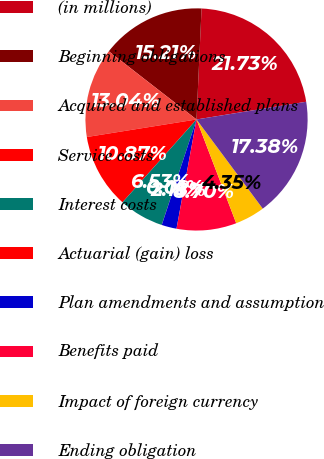Convert chart to OTSL. <chart><loc_0><loc_0><loc_500><loc_500><pie_chart><fcel>(in millions)<fcel>Beginning obligations<fcel>Acquired and established plans<fcel>Service costs<fcel>Interest costs<fcel>Actuarial (gain) loss<fcel>Plan amendments and assumption<fcel>Benefits paid<fcel>Impact of foreign currency<fcel>Ending obligation<nl><fcel>21.73%<fcel>15.21%<fcel>13.04%<fcel>10.87%<fcel>6.53%<fcel>0.01%<fcel>2.18%<fcel>8.7%<fcel>4.35%<fcel>17.38%<nl></chart> 